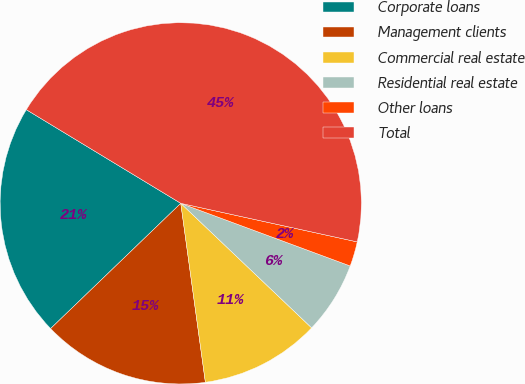Convert chart. <chart><loc_0><loc_0><loc_500><loc_500><pie_chart><fcel>Corporate loans<fcel>Management clients<fcel>Commercial real estate<fcel>Residential real estate<fcel>Other loans<fcel>Total<nl><fcel>20.87%<fcel>14.98%<fcel>10.72%<fcel>6.47%<fcel>2.21%<fcel>44.75%<nl></chart> 